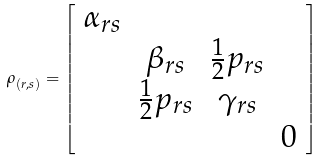Convert formula to latex. <formula><loc_0><loc_0><loc_500><loc_500>\rho _ { \left ( r , s \right ) } = \left [ \begin{array} { c c c c } \alpha _ { r s } & & & \\ & \beta _ { r s } & \frac { 1 } { 2 } p _ { r s } & \\ & \frac { 1 } { 2 } p _ { r s } & \gamma _ { r s } & \\ & & & 0 \end{array} \right ]</formula> 